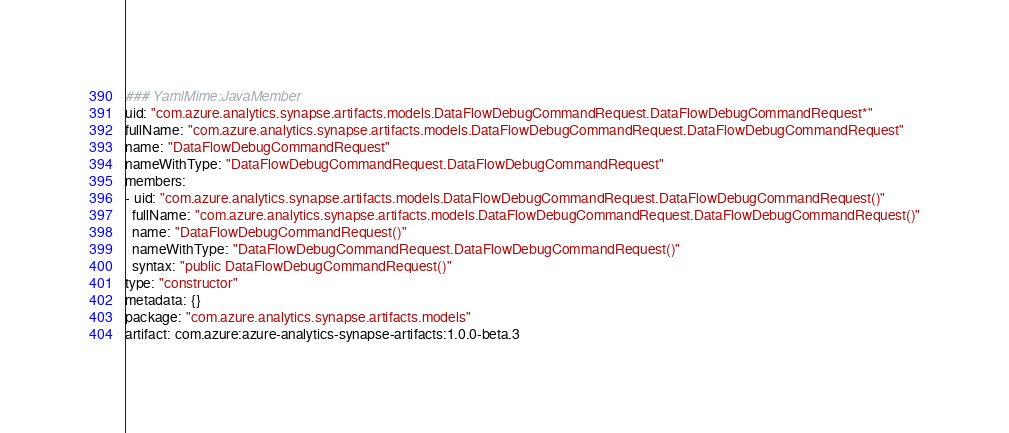Convert code to text. <code><loc_0><loc_0><loc_500><loc_500><_YAML_>### YamlMime:JavaMember
uid: "com.azure.analytics.synapse.artifacts.models.DataFlowDebugCommandRequest.DataFlowDebugCommandRequest*"
fullName: "com.azure.analytics.synapse.artifacts.models.DataFlowDebugCommandRequest.DataFlowDebugCommandRequest"
name: "DataFlowDebugCommandRequest"
nameWithType: "DataFlowDebugCommandRequest.DataFlowDebugCommandRequest"
members:
- uid: "com.azure.analytics.synapse.artifacts.models.DataFlowDebugCommandRequest.DataFlowDebugCommandRequest()"
  fullName: "com.azure.analytics.synapse.artifacts.models.DataFlowDebugCommandRequest.DataFlowDebugCommandRequest()"
  name: "DataFlowDebugCommandRequest()"
  nameWithType: "DataFlowDebugCommandRequest.DataFlowDebugCommandRequest()"
  syntax: "public DataFlowDebugCommandRequest()"
type: "constructor"
metadata: {}
package: "com.azure.analytics.synapse.artifacts.models"
artifact: com.azure:azure-analytics-synapse-artifacts:1.0.0-beta.3
</code> 